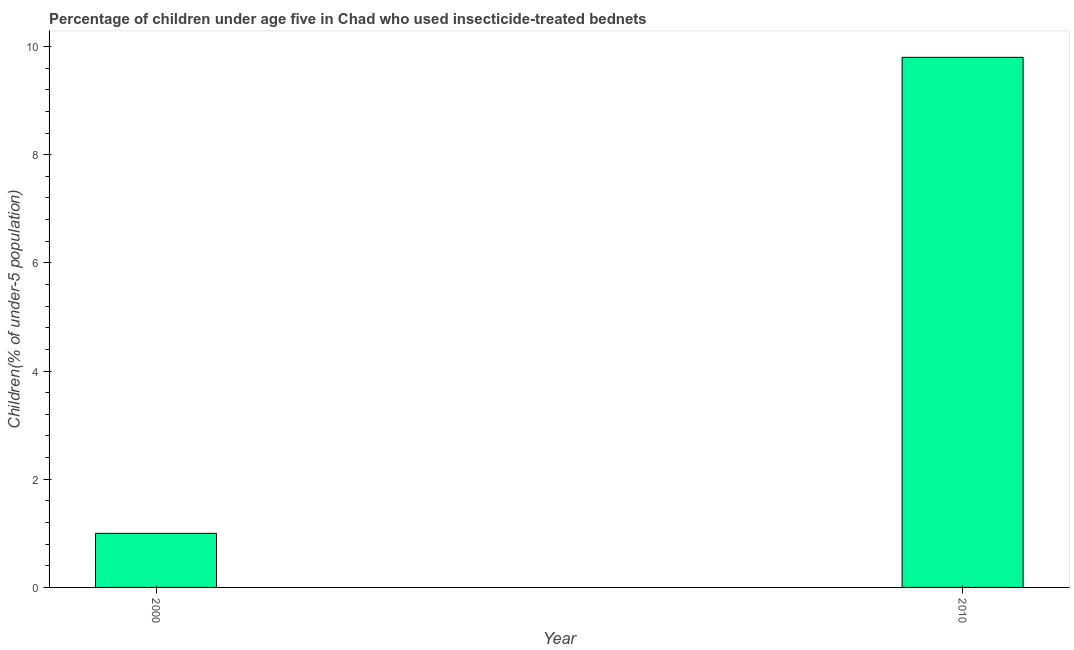Does the graph contain any zero values?
Offer a very short reply. No. Does the graph contain grids?
Your answer should be very brief. No. What is the title of the graph?
Ensure brevity in your answer.  Percentage of children under age five in Chad who used insecticide-treated bednets. What is the label or title of the Y-axis?
Offer a very short reply. Children(% of under-5 population). What is the average percentage of children who use of insecticide-treated bed nets per year?
Make the answer very short. 5.4. What is the median percentage of children who use of insecticide-treated bed nets?
Offer a terse response. 5.4. In how many years, is the percentage of children who use of insecticide-treated bed nets greater than 4.4 %?
Provide a succinct answer. 1. Do a majority of the years between 2000 and 2010 (inclusive) have percentage of children who use of insecticide-treated bed nets greater than 9.2 %?
Provide a short and direct response. No. What is the ratio of the percentage of children who use of insecticide-treated bed nets in 2000 to that in 2010?
Offer a very short reply. 0.1. Is the percentage of children who use of insecticide-treated bed nets in 2000 less than that in 2010?
Your answer should be very brief. Yes. How many bars are there?
Keep it short and to the point. 2. Are all the bars in the graph horizontal?
Provide a short and direct response. No. How many years are there in the graph?
Ensure brevity in your answer.  2. What is the difference between two consecutive major ticks on the Y-axis?
Offer a terse response. 2. Are the values on the major ticks of Y-axis written in scientific E-notation?
Offer a terse response. No. What is the Children(% of under-5 population) in 2000?
Keep it short and to the point. 1. What is the ratio of the Children(% of under-5 population) in 2000 to that in 2010?
Your response must be concise. 0.1. 